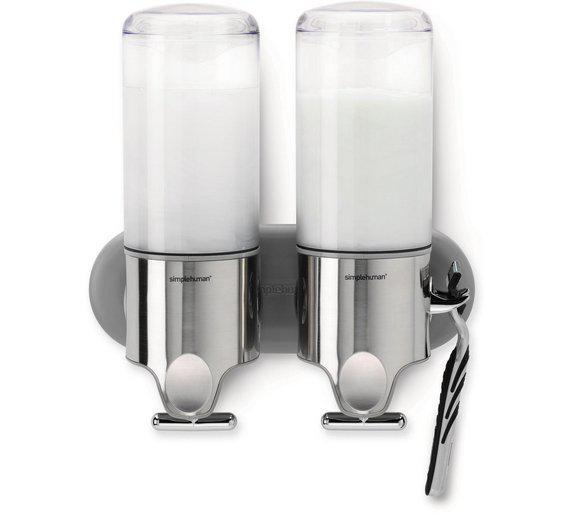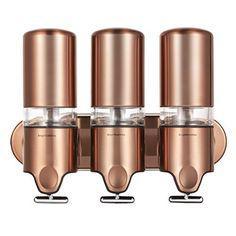The first image is the image on the left, the second image is the image on the right. For the images displayed, is the sentence "Both the top and bottom of three dispensers are made from shiny metallic material." factually correct? Answer yes or no. Yes. The first image is the image on the left, the second image is the image on the right. For the images shown, is this caption "blue liquid is on the far left dispenser" true? Answer yes or no. No. 